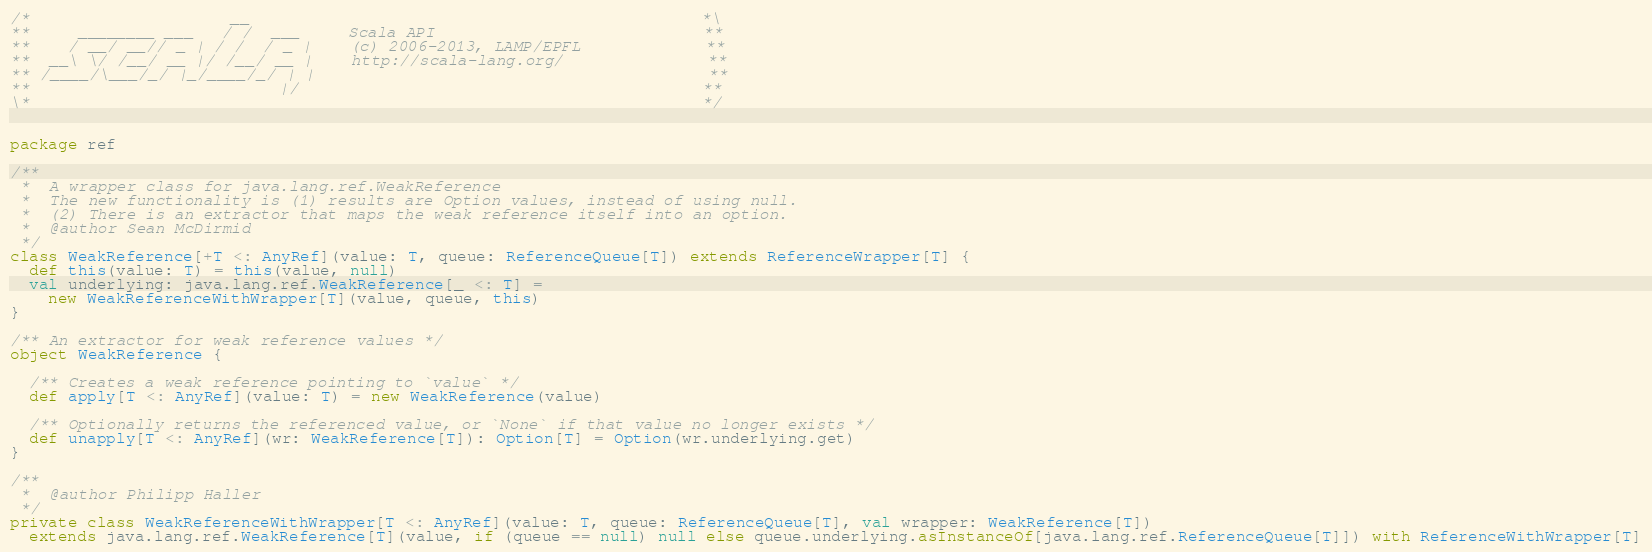Convert code to text. <code><loc_0><loc_0><loc_500><loc_500><_Scala_>/*                     __                                               *\
**     ________ ___   / /  ___     Scala API                            **
**    / __/ __// _ | / /  / _ |    (c) 2006-2013, LAMP/EPFL             **
**  __\ \/ /__/ __ |/ /__/ __ |    http://scala-lang.org/               **
** /____/\___/_/ |_/____/_/ | |                                         **
**                          |/                                          **
\*                                                                      */


package ref

/**
 *  A wrapper class for java.lang.ref.WeakReference
 *  The new functionality is (1) results are Option values, instead of using null.
 *  (2) There is an extractor that maps the weak reference itself into an option.
 *  @author Sean McDirmid
 */
class WeakReference[+T <: AnyRef](value: T, queue: ReferenceQueue[T]) extends ReferenceWrapper[T] {
  def this(value: T) = this(value, null)
  val underlying: java.lang.ref.WeakReference[_ <: T] =
    new WeakReferenceWithWrapper[T](value, queue, this)
}

/** An extractor for weak reference values */
object WeakReference {

  /** Creates a weak reference pointing to `value` */
  def apply[T <: AnyRef](value: T) = new WeakReference(value)

  /** Optionally returns the referenced value, or `None` if that value no longer exists */
  def unapply[T <: AnyRef](wr: WeakReference[T]): Option[T] = Option(wr.underlying.get)
}

/**
 *  @author Philipp Haller
 */
private class WeakReferenceWithWrapper[T <: AnyRef](value: T, queue: ReferenceQueue[T], val wrapper: WeakReference[T])
  extends java.lang.ref.WeakReference[T](value, if (queue == null) null else queue.underlying.asInstanceOf[java.lang.ref.ReferenceQueue[T]]) with ReferenceWithWrapper[T]
</code> 